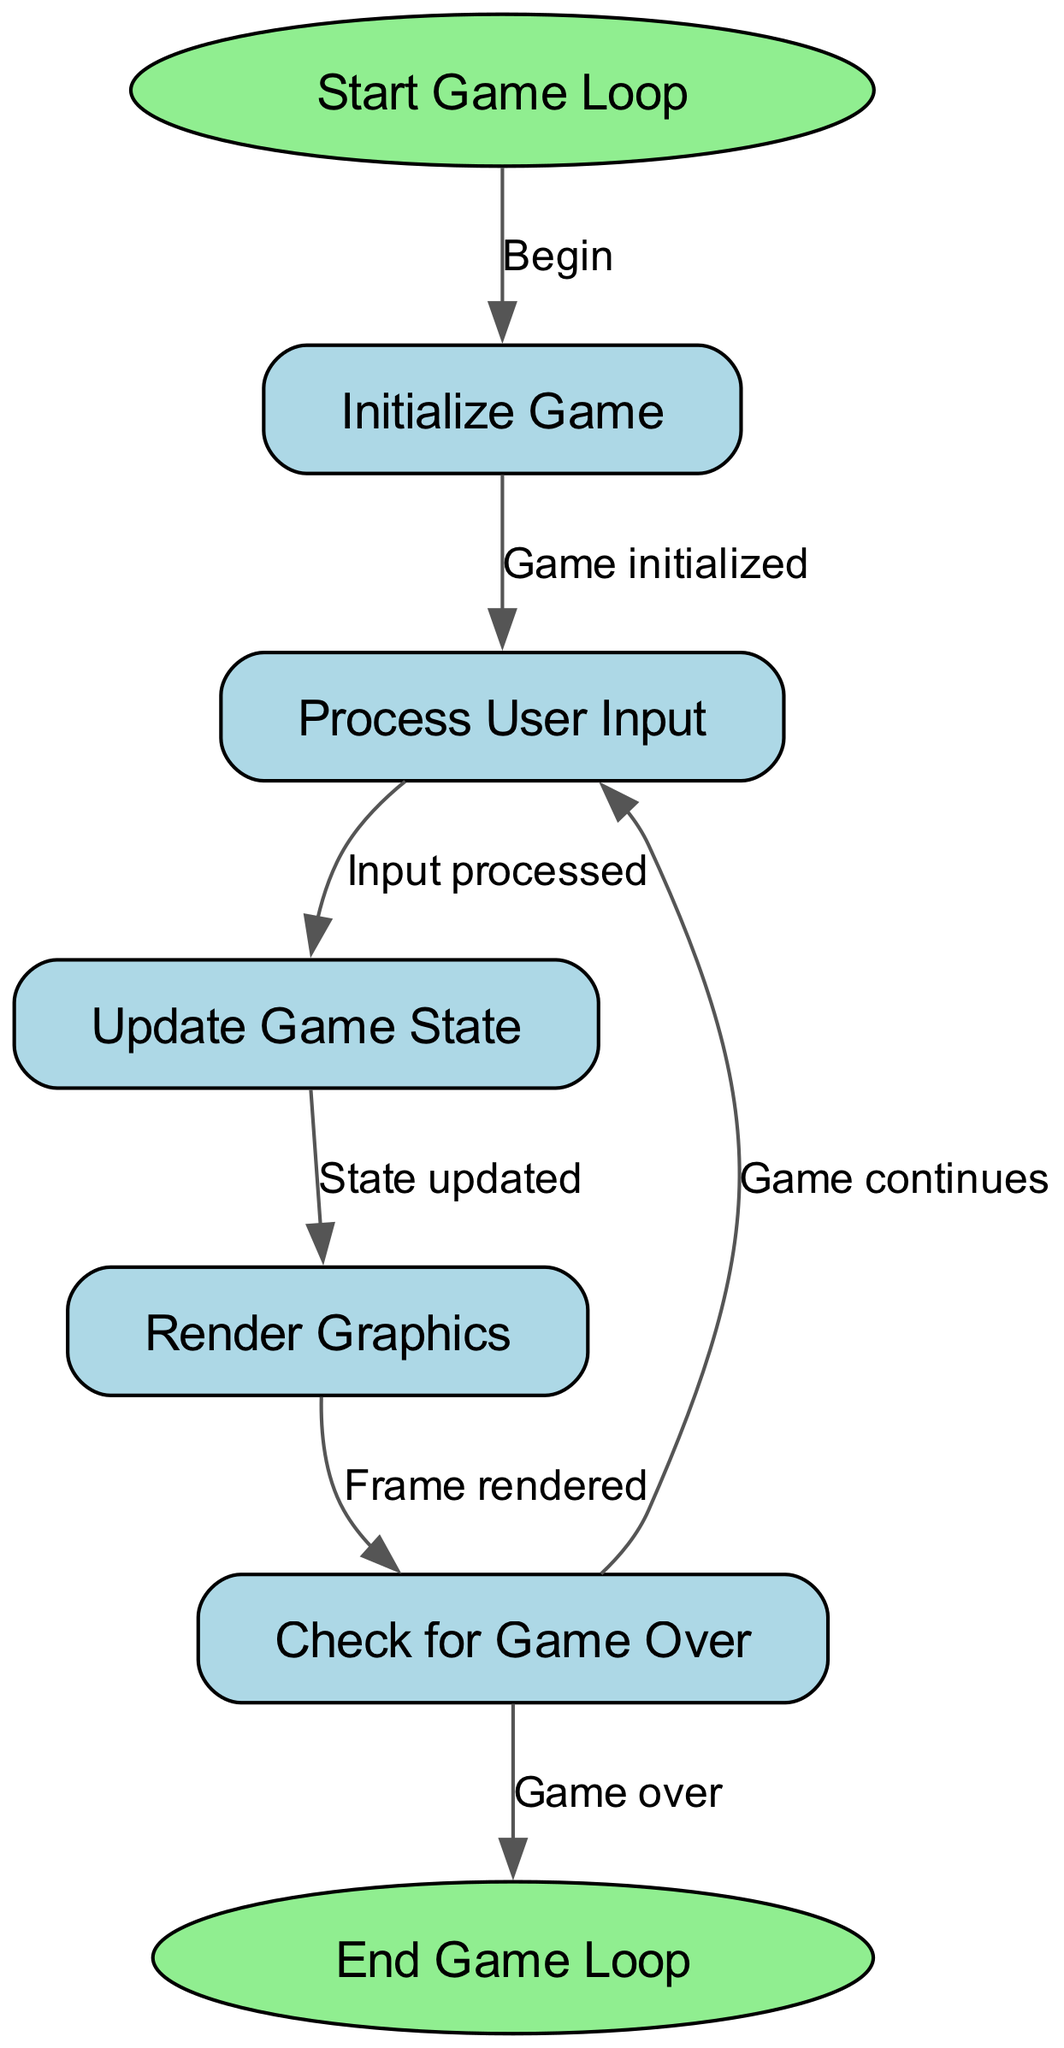What is the first step in the game loop? The first step is indicated by the "Start Game Loop" node, which is connected to the "Initialize Game" node. This shows that the game loop initiates with starting the game.
Answer: Start Game Loop How many nodes are present in the diagram? The diagram consists of 7 nodes: Start Game Loop, Initialize Game, Process User Input, Update Game State, Render Graphics, Check for Game Over, and End Game Loop. Counting these nodes gives a total of 7.
Answer: 7 What happens after "Render Graphics"? Once the "Render Graphics" process is completed, the flowchart indicates that it proceeds to the "Check for Game Over" node, showing that rendering is done before checking if the game should continue.
Answer: Check for Game Over How many edges connect the nodes in the diagram? There are a total of 6 edges connecting the nodes. Each edge shows the directional flow from one node to another, counting them reveals that there are 6 connections.
Answer: 6 What is the output if "Check for Game Over" leads to "End Game Loop"? If the "Check for Game Over" node leads to "End Game Loop," it indicates that the game has finished and will terminate, which is one possible outcome during the game loop.
Answer: Game over What does the edge connection "Process User Input" to "Update Game State" signify? This edge signifies that after the player's input has been processed in the "Process User Input" node, the next logical step in the game loop is to update the game's state according to the input received, reflecting actions taken by the player.
Answer: Input processed What will happen if the result of "Check for Game Over" is "Game continues"? If the result of "Check for Game Over" leads back to "Process User Input," it indicates that the game loop resumes, allowing for further input from the user, and continues the game session.
Answer: Game continues 